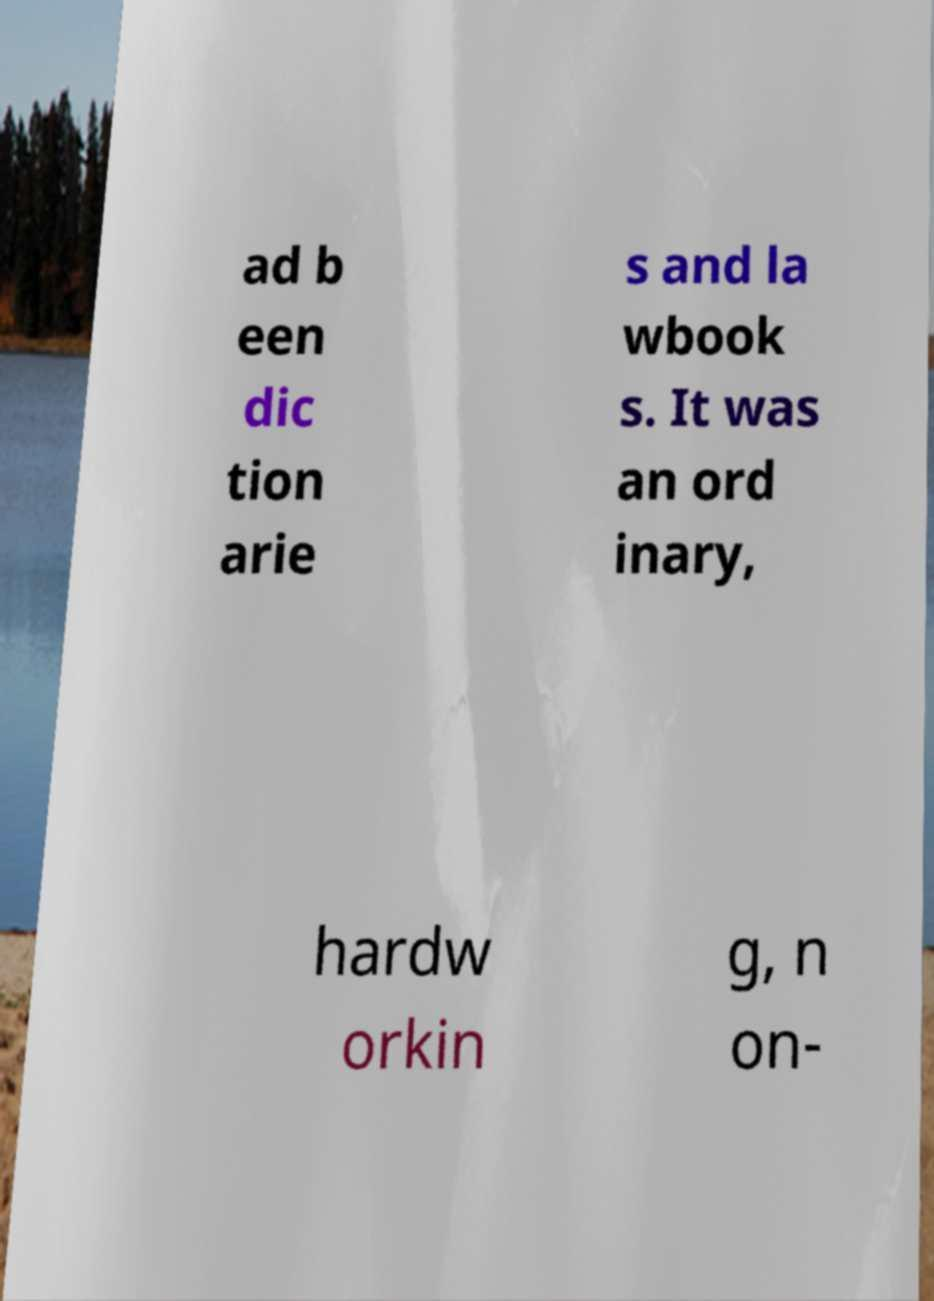Can you accurately transcribe the text from the provided image for me? ad b een dic tion arie s and la wbook s. It was an ord inary, hardw orkin g, n on- 